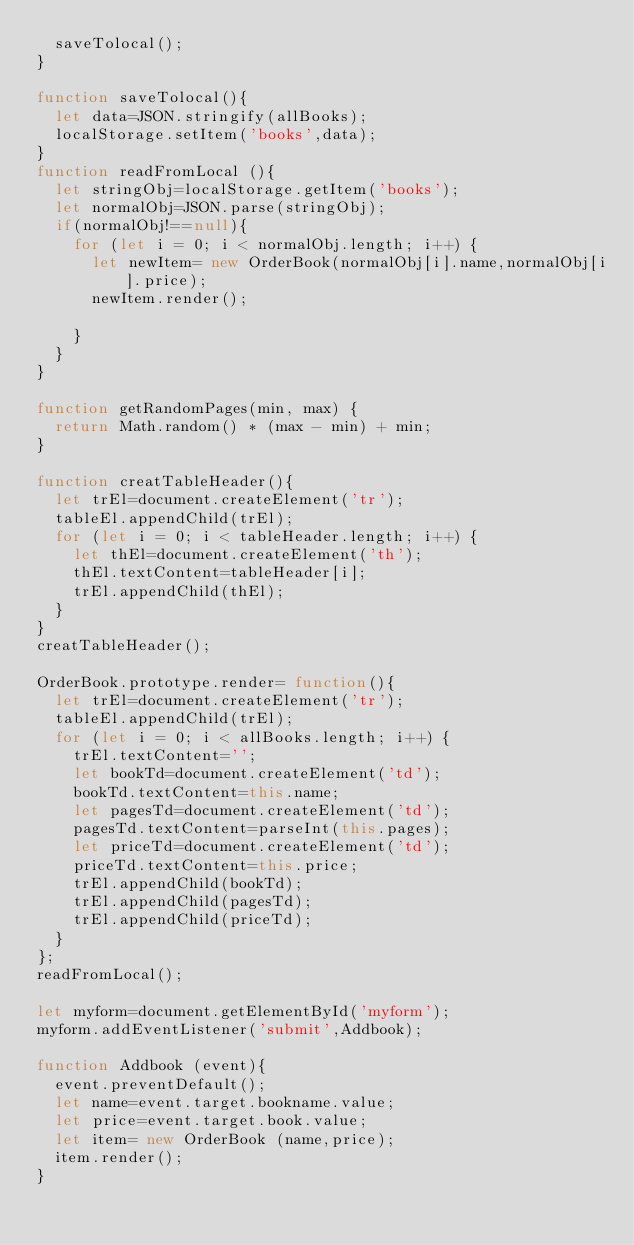<code> <loc_0><loc_0><loc_500><loc_500><_JavaScript_>  saveTolocal();
}

function saveTolocal(){
  let data=JSON.stringify(allBooks);
  localStorage.setItem('books',data);
}
function readFromLocal (){
  let stringObj=localStorage.getItem('books');
  let normalObj=JSON.parse(stringObj);
  if(normalObj!==null){
    for (let i = 0; i < normalObj.length; i++) {
      let newItem= new OrderBook(normalObj[i].name,normalObj[i].price);
      newItem.render();

    }
  }
}

function getRandomPages(min, max) {
  return Math.random() * (max - min) + min;
}

function creatTableHeader(){
  let trEl=document.createElement('tr');
  tableEl.appendChild(trEl);
  for (let i = 0; i < tableHeader.length; i++) {
    let thEl=document.createElement('th');
    thEl.textContent=tableHeader[i];
    trEl.appendChild(thEl);
  }
}
creatTableHeader();

OrderBook.prototype.render= function(){
  let trEl=document.createElement('tr');
  tableEl.appendChild(trEl);
  for (let i = 0; i < allBooks.length; i++) {
    trEl.textContent='';
    let bookTd=document.createElement('td');
    bookTd.textContent=this.name;
    let pagesTd=document.createElement('td');
    pagesTd.textContent=parseInt(this.pages);
    let priceTd=document.createElement('td');
    priceTd.textContent=this.price;
    trEl.appendChild(bookTd);
    trEl.appendChild(pagesTd);
    trEl.appendChild(priceTd);
  }
};
readFromLocal();

let myform=document.getElementById('myform');
myform.addEventListener('submit',Addbook);

function Addbook (event){
  event.preventDefault();
  let name=event.target.bookname.value;
  let price=event.target.book.value;
  let item= new OrderBook (name,price);
  item.render();
}

</code> 